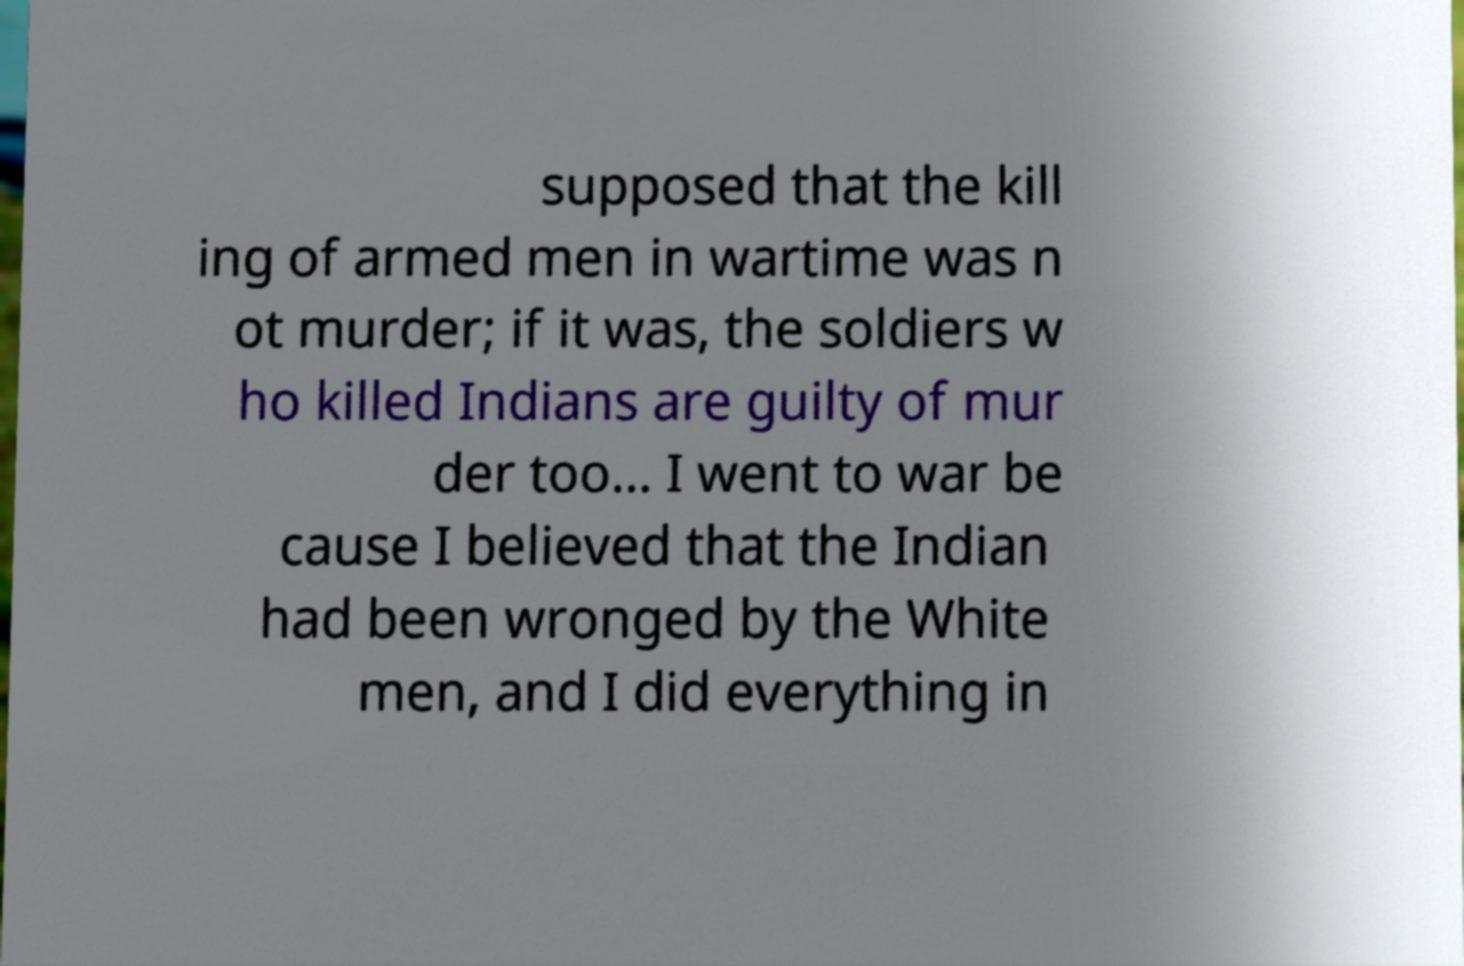Could you extract and type out the text from this image? supposed that the kill ing of armed men in wartime was n ot murder; if it was, the soldiers w ho killed Indians are guilty of mur der too... I went to war be cause I believed that the Indian had been wronged by the White men, and I did everything in 